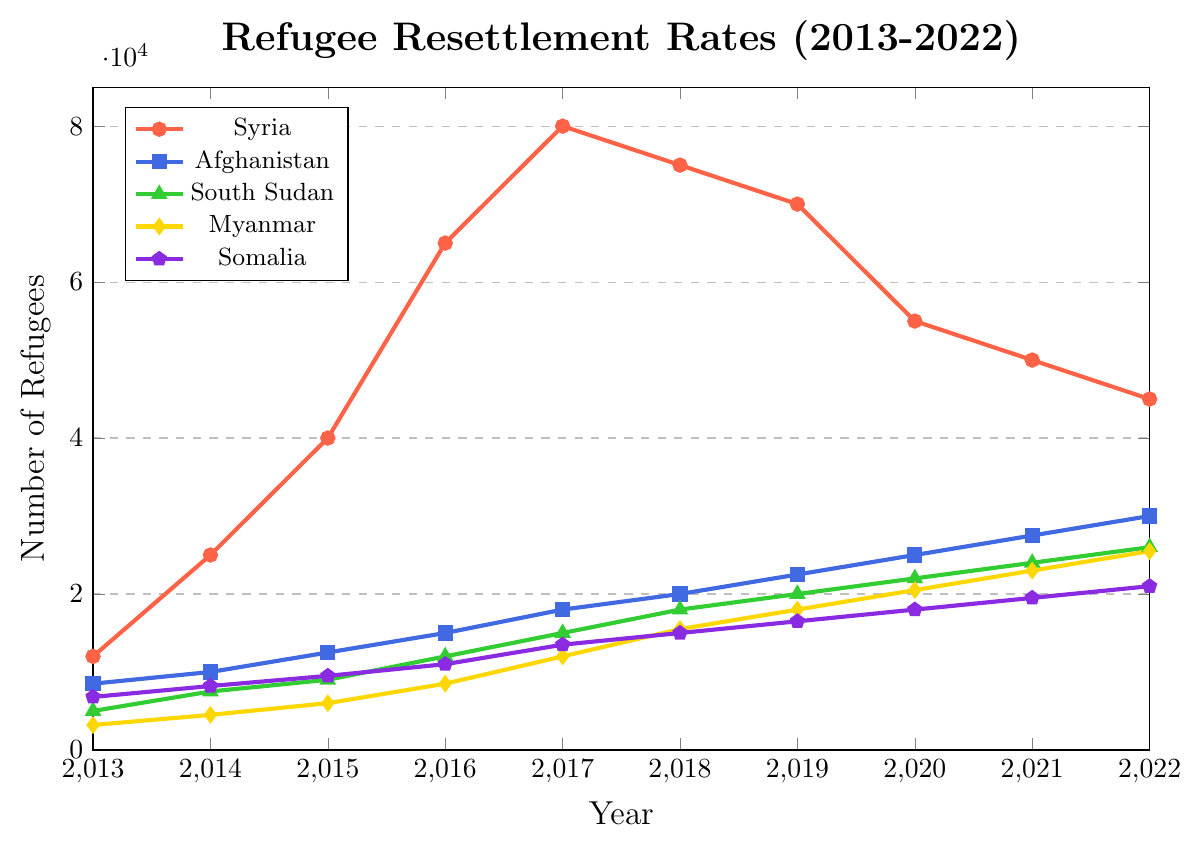What is the trend of refugee resettlement from Syria over the past decade? The plot shows resettlement numbers for Syria over the years. From the data, it begins at 12,000 in 2013 and peaks at 80,000 in 2017 before gradually decreasing to 45,000 by 2022. The overall trend indicates an initial increase followed by a decrease.
Answer: Initial increase, then decrease Which country of origin had the highest number of refugees resettled in 2017? By examining the peaks of each plotted line for the year 2017, Syria has the highest number at 80,000 refugees resettled in that year.
Answer: Syria In what year did Myanmar surpass 10,000 refugees resettled for the first time? By tracing the Myanmar line (yellow) on the plot, it surpassed 10,000 refugees for the first time in 2017 where the value was 12,000.
Answer: 2017 How does the resettlement trend for Afghanistan compare to that of Syria? The plot shows that Afghanistan’s resettlement numbers consistently increased from 2013 to 2022, whereas Syria saw a sharp rise until 2017 and then a decline. This indicates that while Afghanistan has a steadily increasing trend, Syria has a peaked and declining trend.
Answer: Afghanistan's increases steadily, Syria's rises then falls What is the difference in the number of resettled refugees between South Sudan and Somalia in 2022? From the plot, South Sudan had 26,000 resettled refugees and Somalia had 21,000 in 2022. The difference is calculated as 26,000 - 21,000 = 5,000.
Answer: 5,000 Which country of origin showed the most steady increase in refugee resettlement over the decade? Observing the plots, Afghanistan (blue line) shows a consistent and steady increase in resettlement numbers from 2013 to 2022 without any significant dips or peaks.
Answer: Afghanistan Between 2018 and 2020, which country saw the largest decrease in resettlement numbers? By comparing the numbers for 2018 and 2020, Syria saw the largest decrease from 75,000 to 55,000 refugees, a drop of 20,000.
Answer: Syria What is the average number of refugees resettled from Somalia over the decade? Summing up Somalia’s resettlement numbers (6800, 8200, 9500, 11000, 13500, 15000, 16500, 18000, 19500, 21000) gives 139000. Dividing by 10 gives an average of 13,900.
Answer: 13,900 